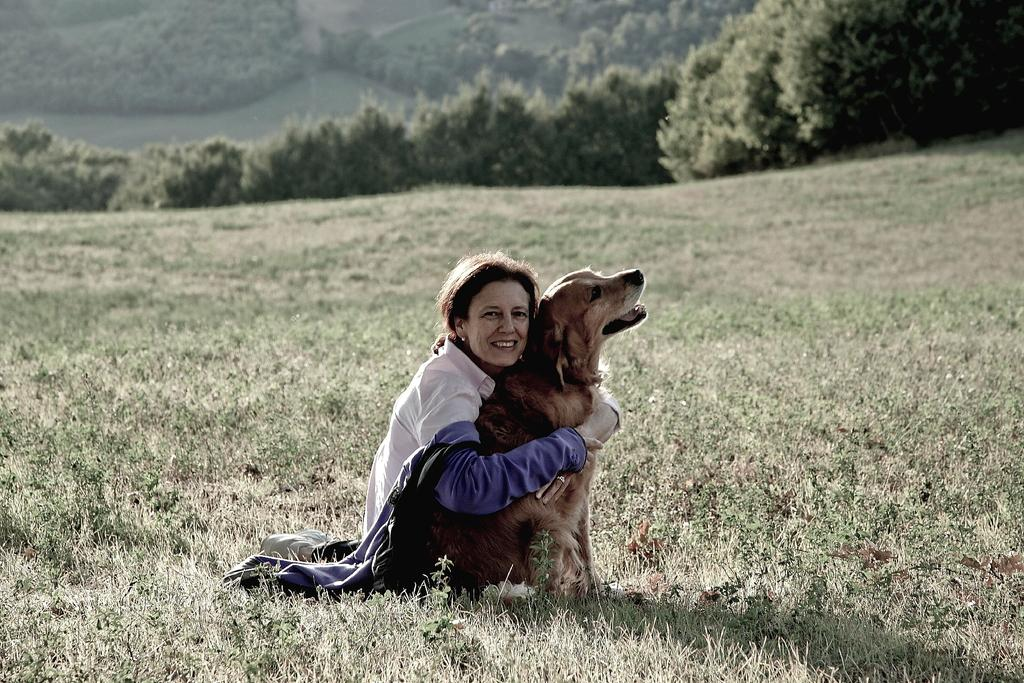Who is present in the image? There is a woman in the image. What is the woman doing in the image? The woman is seated and holding a dog with both hands. What is the woman wearing in the image? The woman is wearing a blue jacket. How does the woman appear to feel in the image? The woman has a smile on her face, indicating a positive emotion. What can be seen in the background of the image? There are trees visible in the image. What type of destruction can be seen in the image? There is no destruction present in the image; it features a woman holding a dog and smiling. How many tickets are visible in the image? There are no tickets present in the image. 